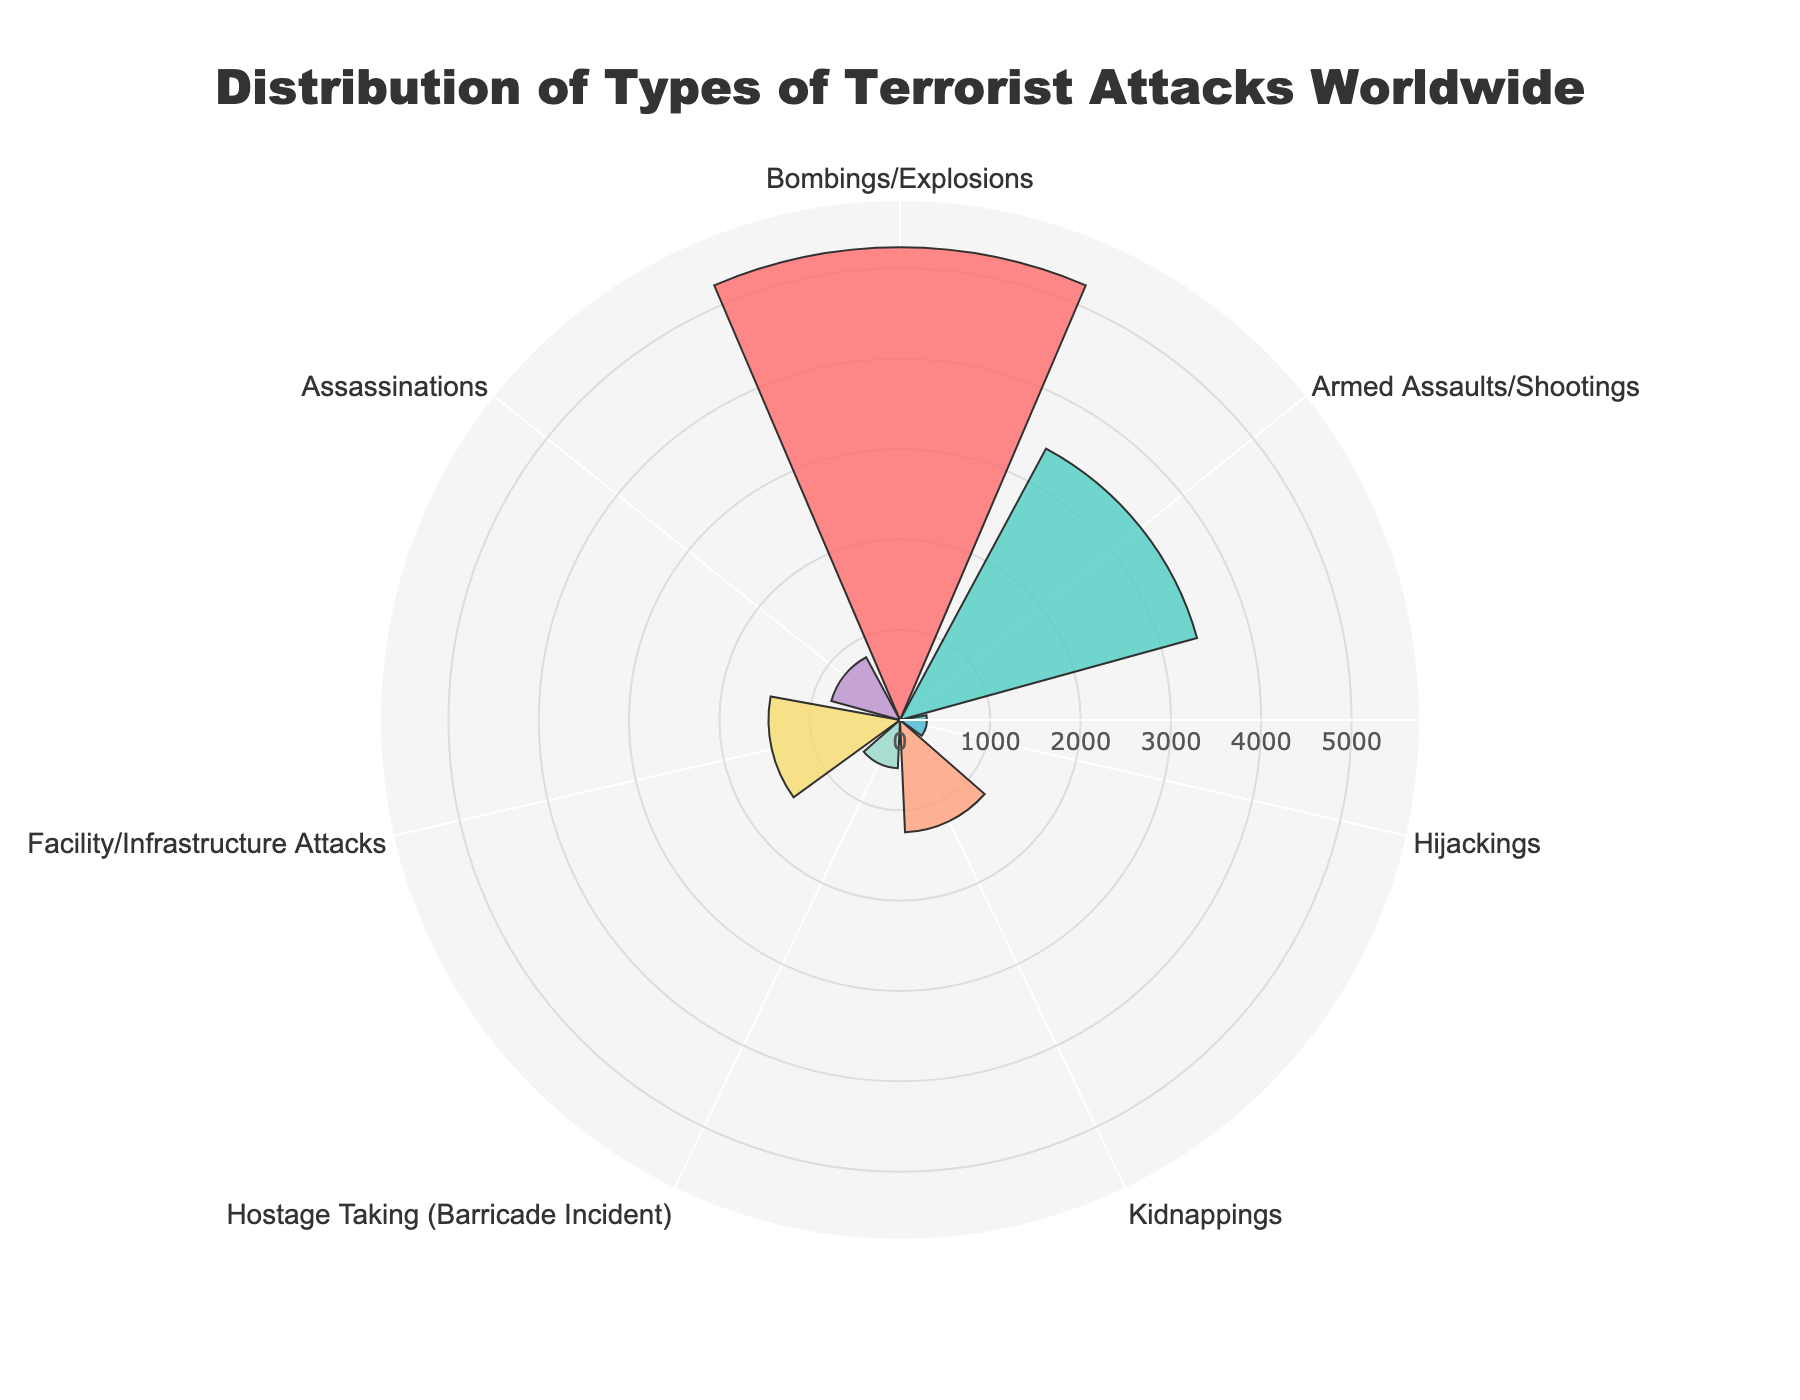what is the highest value category represented in the chart? The 'Bombings/Explosions' category has the highest value. This is visible by looking at the length of the corresponding radial bar, which extends the furthest.
Answer: Bombings/Explosions how many categories are shown in the chart? The chart displays a total of seven distinct categories, each represented by a radial bar.
Answer: 7 which category has the smallest value in the chart? The 'Hijackings' category has the smallest value. This can be observed as it has the shortest radial bar.
Answer: Hijackings how much larger is the value for 'Bombings/Explosions' compared to 'Hijackings'? The value for 'Bombings/Explosions' is 5234 and for 'Hijackings' is 298. The difference is calculated as 5234 - 298 = 4936.
Answer: 4936 what is the sum of the values for 'Kidnappings' and 'Assassinations'? The value for 'Kidnappings' is 1245 and for 'Assassinations' is 789. The sum is 1245 + 789 = 2034.
Answer: 2034 which category has a value closest to 3000? The 'Armed Assaults/Shootings' category is closest to 3000 with a value of 3412.
Answer: Armed Assaults/Shootings compare the values of 'Facility/Infrastructure Attacks' and 'Hostage Taking (Barricade Incident)'. Which is higher and by how much? 'Facility/Infrastructure Attacks' has a value of 1456, whereas 'Hostage Taking (Barricade Incident)' has a value of 534. The difference is 1456 - 534 = 922, making 'Facility/Infrastructure Attacks' higher by 922.
Answer: Facility/Infrastructure Attacks by 922 what is the average value of all categories? To find the average value, sum all values: 5234 + 3412 + 298 + 1245 + 534 + 1456 + 789 = 12968. Divide this by the number of categories, which is 7. The average is 12968 / 7 ≈ 1852.57.
Answer: 1852.57 in the polar area chart, which color represents the 'Armed Assaults/Shootings' category? The 'Armed Assaults/Shootings' category is represented by a specific color, which can be identified based on the chart's legend or bar color. In this case, it is visually represented by turquoise.
Answer: turquoise is the value of 'Kidnappings' more than double the value of 'Assassinations'? The value of 'Kidnappings' is 1245, and double the value of 'Assassinations' is 789 * 2 = 1578. Since 1245 is less than 1578, 'Kidnappings' is not more than double.
Answer: No 